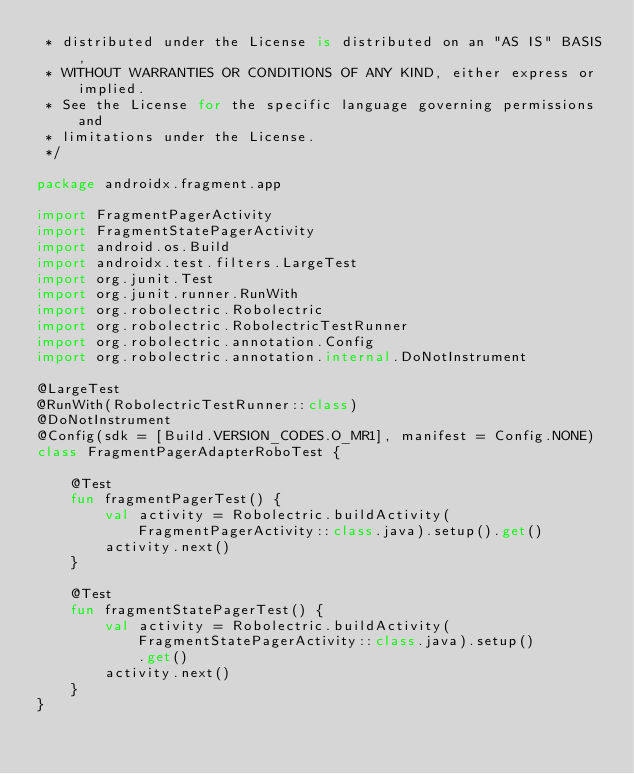Convert code to text. <code><loc_0><loc_0><loc_500><loc_500><_Kotlin_> * distributed under the License is distributed on an "AS IS" BASIS,
 * WITHOUT WARRANTIES OR CONDITIONS OF ANY KIND, either express or implied.
 * See the License for the specific language governing permissions and
 * limitations under the License.
 */

package androidx.fragment.app

import FragmentPagerActivity
import FragmentStatePagerActivity
import android.os.Build
import androidx.test.filters.LargeTest
import org.junit.Test
import org.junit.runner.RunWith
import org.robolectric.Robolectric
import org.robolectric.RobolectricTestRunner
import org.robolectric.annotation.Config
import org.robolectric.annotation.internal.DoNotInstrument

@LargeTest
@RunWith(RobolectricTestRunner::class)
@DoNotInstrument
@Config(sdk = [Build.VERSION_CODES.O_MR1], manifest = Config.NONE)
class FragmentPagerAdapterRoboTest {

    @Test
    fun fragmentPagerTest() {
        val activity = Robolectric.buildActivity(FragmentPagerActivity::class.java).setup().get()
        activity.next()
    }

    @Test
    fun fragmentStatePagerTest() {
        val activity = Robolectric.buildActivity(FragmentStatePagerActivity::class.java).setup()
            .get()
        activity.next()
    }
}
</code> 